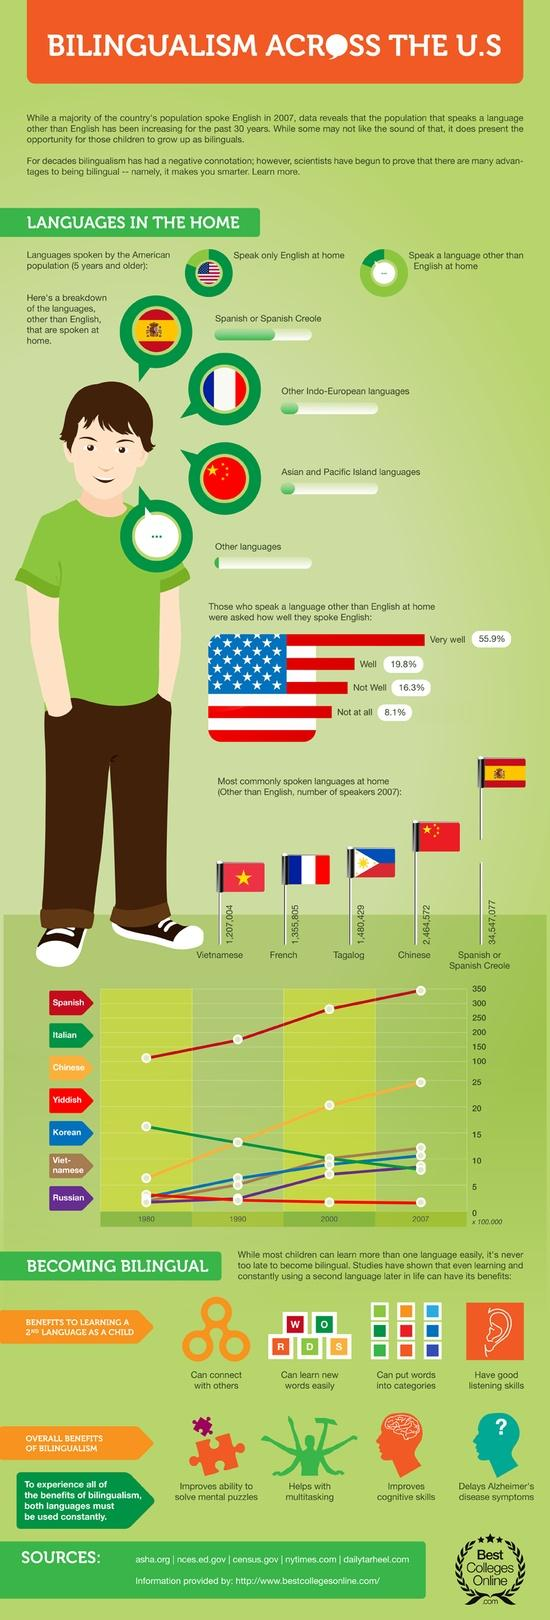Draw attention to some important aspects in this diagram. Chinese was the second most spoken language, other than English, in 2007. From 1980 to 2007, the number of people speaking Yiddish and Italian decreased significantly. French is the fourth most spoken language, excluding English, in 2007. Bilingualism is what makes me smarter. According to the given data, 8.1% of the people did not speak English at all. 